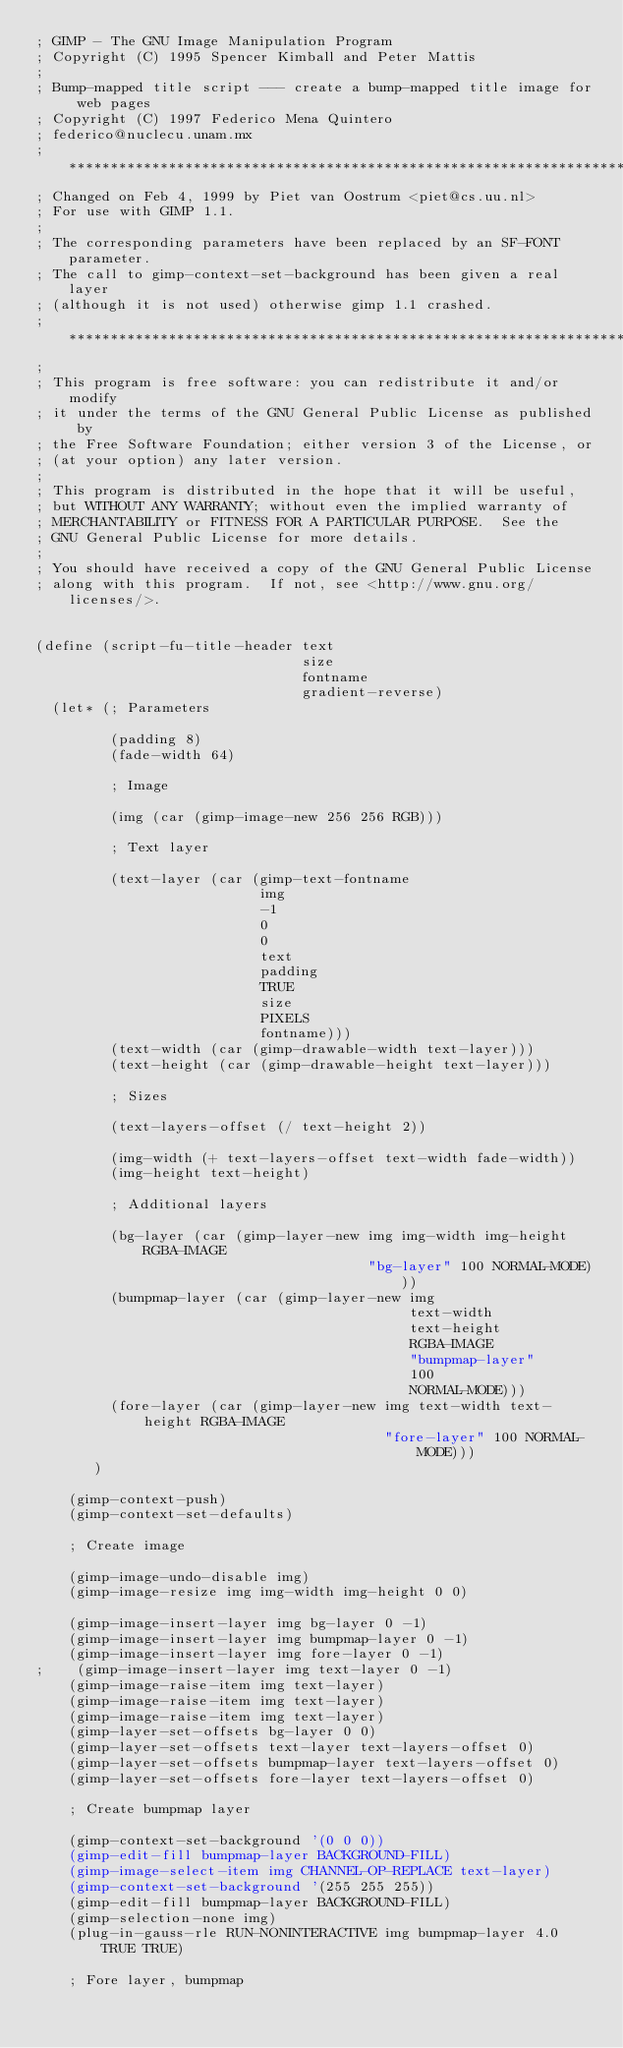<code> <loc_0><loc_0><loc_500><loc_500><_Scheme_>; GIMP - The GNU Image Manipulation Program
; Copyright (C) 1995 Spencer Kimball and Peter Mattis
;
; Bump-mapped title script --- create a bump-mapped title image for web pages
; Copyright (C) 1997 Federico Mena Quintero
; federico@nuclecu.unam.mx
; ************************************************************************
; Changed on Feb 4, 1999 by Piet van Oostrum <piet@cs.uu.nl>
; For use with GIMP 1.1.
;
; The corresponding parameters have been replaced by an SF-FONT parameter.
; The call to gimp-context-set-background has been given a real layer
; (although it is not used) otherwise gimp 1.1 crashed.
; ************************************************************************
;
; This program is free software: you can redistribute it and/or modify
; it under the terms of the GNU General Public License as published by
; the Free Software Foundation; either version 3 of the License, or
; (at your option) any later version.
;
; This program is distributed in the hope that it will be useful,
; but WITHOUT ANY WARRANTY; without even the implied warranty of
; MERCHANTABILITY or FITNESS FOR A PARTICULAR PURPOSE.  See the
; GNU General Public License for more details.
;
; You should have received a copy of the GNU General Public License
; along with this program.  If not, see <http://www.gnu.org/licenses/>.


(define (script-fu-title-header text
                                size
                                fontname
                                gradient-reverse)
  (let* (; Parameters

         (padding 8)
         (fade-width 64)

         ; Image

         (img (car (gimp-image-new 256 256 RGB)))

         ; Text layer

         (text-layer (car (gimp-text-fontname
                           img
                           -1
                           0
                           0
                           text
                           padding
                           TRUE
                           size
                           PIXELS
                           fontname)))
         (text-width (car (gimp-drawable-width text-layer)))
         (text-height (car (gimp-drawable-height text-layer)))

         ; Sizes

         (text-layers-offset (/ text-height 2))

         (img-width (+ text-layers-offset text-width fade-width))
         (img-height text-height)

         ; Additional layers

         (bg-layer (car (gimp-layer-new img img-width img-height RGBA-IMAGE
                                        "bg-layer" 100 NORMAL-MODE)))
         (bumpmap-layer (car (gimp-layer-new img
                                             text-width
                                             text-height
                                             RGBA-IMAGE
                                             "bumpmap-layer"
                                             100
                                             NORMAL-MODE)))
         (fore-layer (car (gimp-layer-new img text-width text-height RGBA-IMAGE
                                          "fore-layer" 100 NORMAL-MODE)))
       )

    (gimp-context-push)
    (gimp-context-set-defaults)

    ; Create image

    (gimp-image-undo-disable img)
    (gimp-image-resize img img-width img-height 0 0)

    (gimp-image-insert-layer img bg-layer 0 -1)
    (gimp-image-insert-layer img bumpmap-layer 0 -1)
    (gimp-image-insert-layer img fore-layer 0 -1)
;    (gimp-image-insert-layer img text-layer 0 -1)
    (gimp-image-raise-item img text-layer)
    (gimp-image-raise-item img text-layer)
    (gimp-image-raise-item img text-layer)
    (gimp-layer-set-offsets bg-layer 0 0)
    (gimp-layer-set-offsets text-layer text-layers-offset 0)
    (gimp-layer-set-offsets bumpmap-layer text-layers-offset 0)
    (gimp-layer-set-offsets fore-layer text-layers-offset 0)

    ; Create bumpmap layer

    (gimp-context-set-background '(0 0 0))
    (gimp-edit-fill bumpmap-layer BACKGROUND-FILL)
    (gimp-image-select-item img CHANNEL-OP-REPLACE text-layer)
    (gimp-context-set-background '(255 255 255))
    (gimp-edit-fill bumpmap-layer BACKGROUND-FILL)
    (gimp-selection-none img)
    (plug-in-gauss-rle RUN-NONINTERACTIVE img bumpmap-layer 4.0 TRUE TRUE)

    ; Fore layer, bumpmap
</code> 